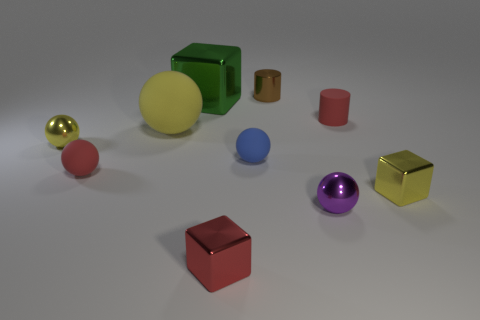Subtract all red balls. How many balls are left? 4 Subtract all small blue matte spheres. How many spheres are left? 4 Subtract all green spheres. Subtract all yellow cubes. How many spheres are left? 5 Subtract all blocks. How many objects are left? 7 Add 10 big gray metallic things. How many big gray metallic things exist? 10 Subtract 1 red cylinders. How many objects are left? 9 Subtract all small red things. Subtract all tiny matte things. How many objects are left? 4 Add 8 tiny purple metallic objects. How many tiny purple metallic objects are left? 9 